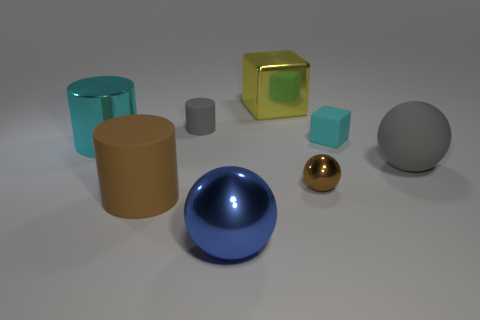What number of cyan shiny things are the same size as the brown metal object?
Provide a short and direct response. 0. There is a shiny ball in front of the tiny sphere; is its size the same as the rubber object that is in front of the big gray thing?
Provide a short and direct response. Yes. What is the shape of the large shiny object that is behind the big metallic sphere and in front of the large yellow shiny block?
Offer a terse response. Cylinder. Is there a large rubber cylinder that has the same color as the matte sphere?
Provide a succinct answer. No. Is there a small cylinder?
Provide a succinct answer. Yes. The big metallic thing behind the cyan shiny cylinder is what color?
Offer a terse response. Yellow. There is a cyan metallic cylinder; is its size the same as the rubber cylinder in front of the tiny brown sphere?
Your response must be concise. Yes. There is a thing that is both left of the tiny gray matte cylinder and in front of the small brown shiny ball; what is its size?
Offer a terse response. Large. Are there any blocks that have the same material as the big yellow object?
Make the answer very short. No. The big gray thing has what shape?
Your response must be concise. Sphere. 